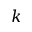<formula> <loc_0><loc_0><loc_500><loc_500>k</formula> 